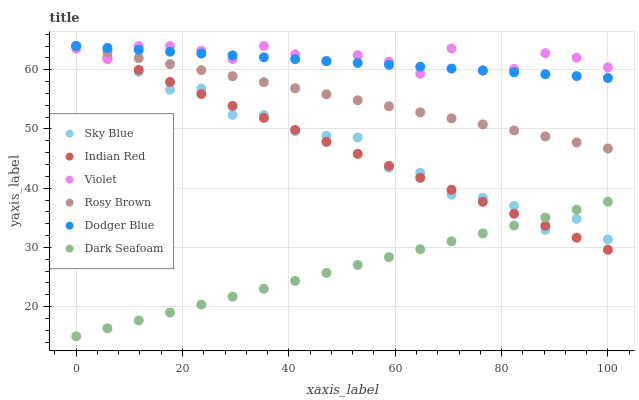Does Dark Seafoam have the minimum area under the curve?
Answer yes or no. Yes. Does Violet have the maximum area under the curve?
Answer yes or no. Yes. Does Dodger Blue have the minimum area under the curve?
Answer yes or no. No. Does Dodger Blue have the maximum area under the curve?
Answer yes or no. No. Is Dark Seafoam the smoothest?
Answer yes or no. Yes. Is Sky Blue the roughest?
Answer yes or no. Yes. Is Dodger Blue the smoothest?
Answer yes or no. No. Is Dodger Blue the roughest?
Answer yes or no. No. Does Dark Seafoam have the lowest value?
Answer yes or no. Yes. Does Dodger Blue have the lowest value?
Answer yes or no. No. Does Sky Blue have the highest value?
Answer yes or no. Yes. Does Dark Seafoam have the highest value?
Answer yes or no. No. Is Dark Seafoam less than Dodger Blue?
Answer yes or no. Yes. Is Rosy Brown greater than Dark Seafoam?
Answer yes or no. Yes. Does Indian Red intersect Dodger Blue?
Answer yes or no. Yes. Is Indian Red less than Dodger Blue?
Answer yes or no. No. Is Indian Red greater than Dodger Blue?
Answer yes or no. No. Does Dark Seafoam intersect Dodger Blue?
Answer yes or no. No. 